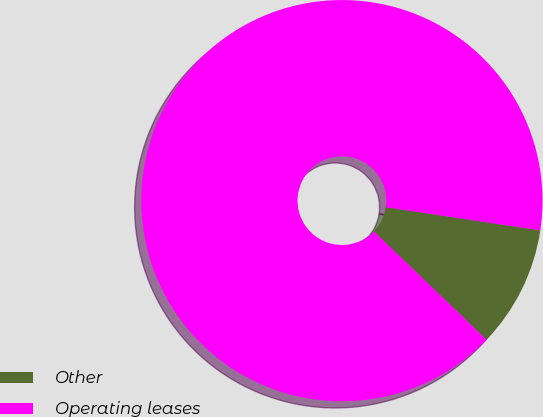Convert chart. <chart><loc_0><loc_0><loc_500><loc_500><pie_chart><fcel>Other<fcel>Operating leases<nl><fcel>9.82%<fcel>90.18%<nl></chart> 